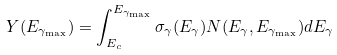<formula> <loc_0><loc_0><loc_500><loc_500>Y ( E _ { \gamma _ { \max } } ) = \int _ { E _ { c } } ^ { E _ { \gamma _ { \max } } } \sigma _ { \gamma } ( E _ { \gamma } ) N ( E _ { \gamma } , E _ { \gamma _ { \max } } ) d E _ { \gamma }</formula> 